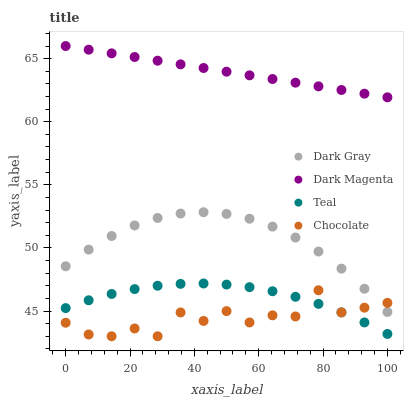Does Chocolate have the minimum area under the curve?
Answer yes or no. Yes. Does Dark Magenta have the maximum area under the curve?
Answer yes or no. Yes. Does Teal have the minimum area under the curve?
Answer yes or no. No. Does Teal have the maximum area under the curve?
Answer yes or no. No. Is Dark Magenta the smoothest?
Answer yes or no. Yes. Is Chocolate the roughest?
Answer yes or no. Yes. Is Teal the smoothest?
Answer yes or no. No. Is Teal the roughest?
Answer yes or no. No. Does Chocolate have the lowest value?
Answer yes or no. Yes. Does Teal have the lowest value?
Answer yes or no. No. Does Dark Magenta have the highest value?
Answer yes or no. Yes. Does Teal have the highest value?
Answer yes or no. No. Is Teal less than Dark Magenta?
Answer yes or no. Yes. Is Dark Magenta greater than Chocolate?
Answer yes or no. Yes. Does Dark Gray intersect Chocolate?
Answer yes or no. Yes. Is Dark Gray less than Chocolate?
Answer yes or no. No. Is Dark Gray greater than Chocolate?
Answer yes or no. No. Does Teal intersect Dark Magenta?
Answer yes or no. No. 